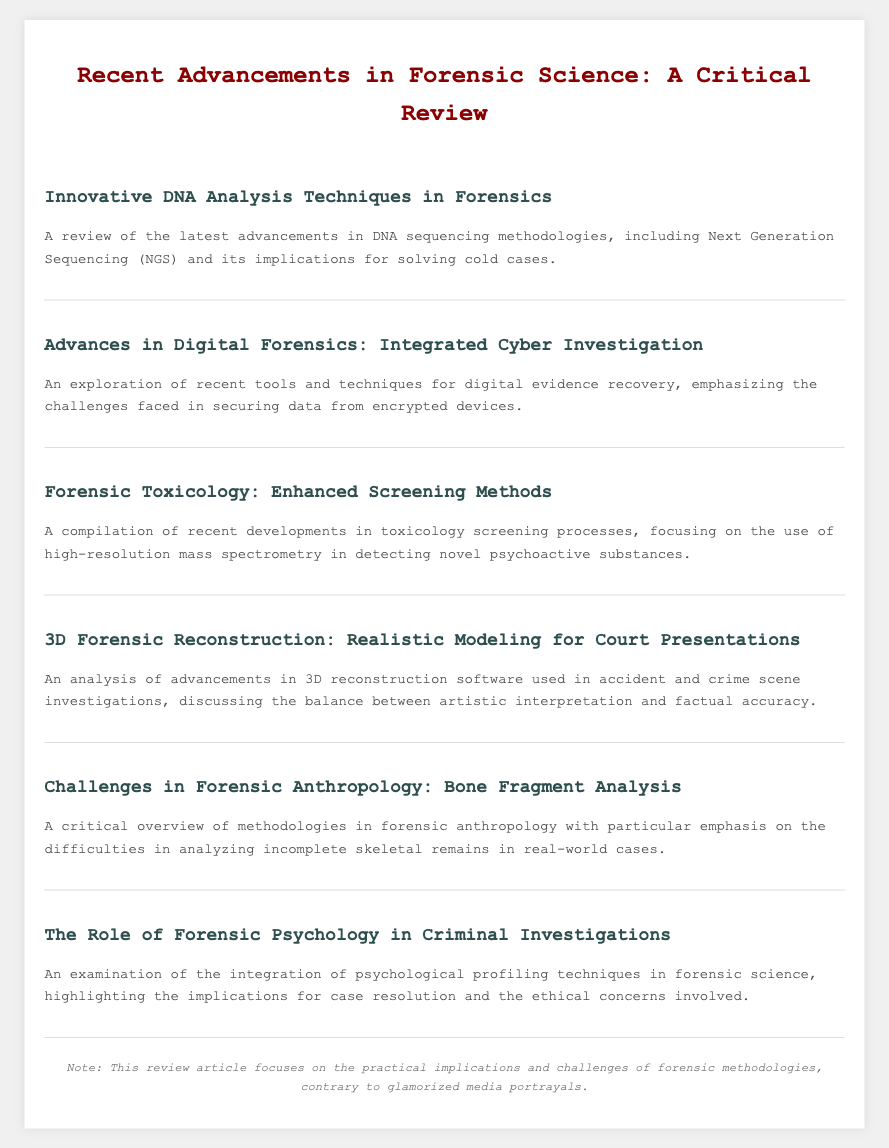What is the title of the review article? The title appears prominently at the top of the document and indicates the primary focus of the content.
Answer: Recent Advancements in Forensic Science: A Critical Review What is the first topic listed in the menu? The first menu item highlights the subject of innovative DNA techniques, as presented in the document.
Answer: Innovative DNA Analysis Techniques in Forensics What technology is mentioned in the context of DNA analysis? Specific advancements relevant to DNA analysis techniques are discussed in the first menu item.
Answer: Next Generation Sequencing (NGS) How many topics are covered in the menu? The total number of distinct menu items can be counted from the document sections.
Answer: Six What is the main challenge emphasized in digital forensics? The second menu item indicates a specific difficulty faced when handling digital evidence.
Answer: Securing data from encrypted devices Which aspect of forensic anthropology is highlighted? The fifth menu item focuses on a particular method in forensic anthropology.
Answer: Bone Fragment Analysis What is emphasized about the use of 3D reconstruction software? The fourth menu item addresses the balance needed in the application of this software in legal contexts.
Answer: Artistic interpretation and factual accuracy What ethical concerns are mentioned in forensic psychology? The sixth menu item indicates that there are critical aspects related to ethics that are considered.
Answer: Ethical concerns 